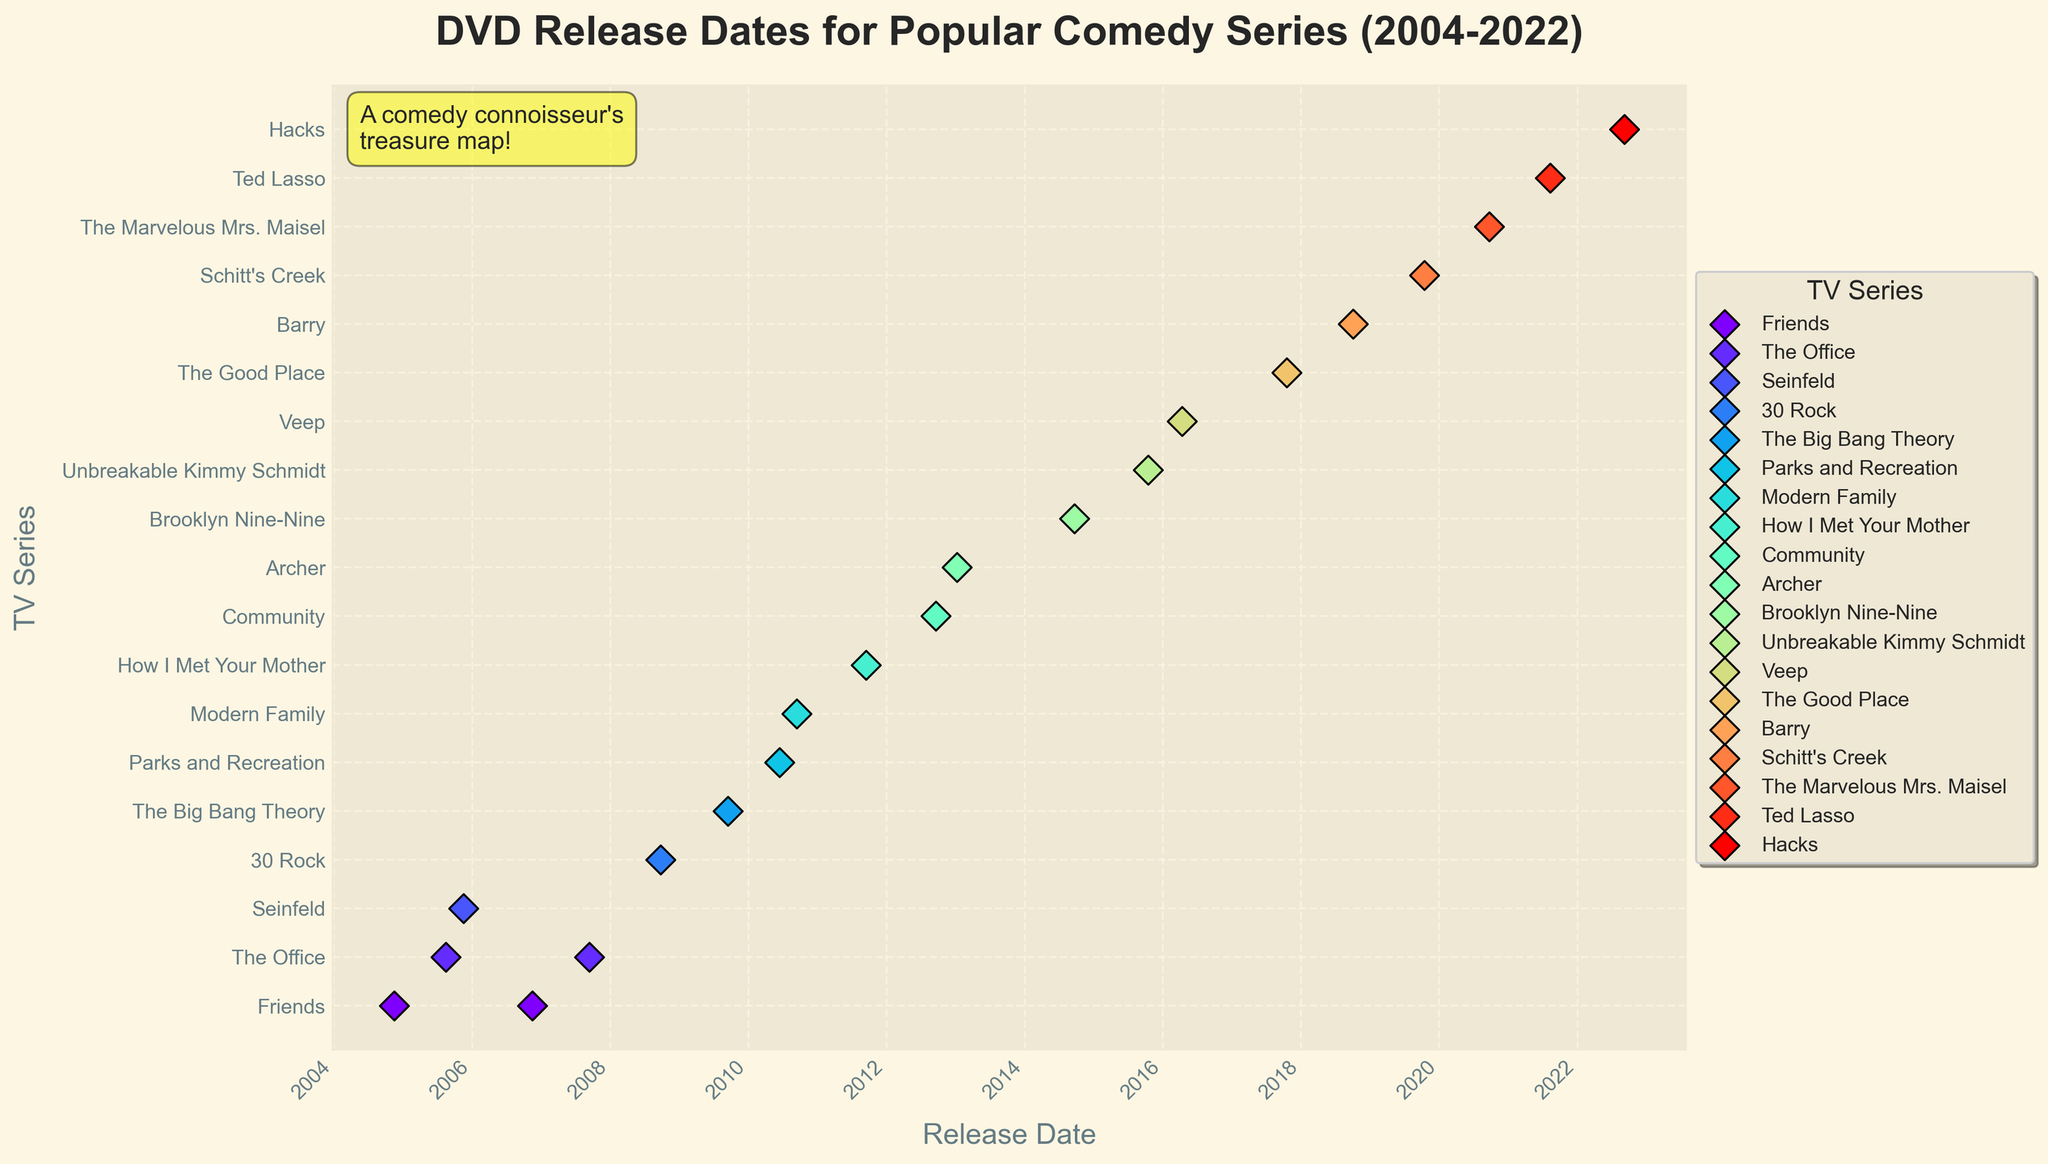What's the title of the figure? The title of the figure is found at the top and usually gives a brief description of what the figure is about. Here, it indicates the topic and timeframe.
Answer: DVD Release Dates for Popular Comedy Series (2004-2022) What are the x-axis and y-axis labels? The labels for the x-axis and y-axis provide information on what the axes represent. In this figure, the x-axis (Release Date) shows the dates, while the y-axis (TV Series) lists the names of the comedy series.
Answer: Release Date, TV Series Which series has the most recent DVD release date? To determine this, look at the latest (most recent) point on the graph along the x-axis.
Answer: Hacks Which series released its complete series DVD in 2006? Since the y-axis lists each series, locate the year 2006 on the x-axis and find the corresponding series in the y-axis label.
Answer: Friends How many series have their DVDs released after 2017? Count the number of data points plotted on the right side of the 2017 mark on the x-axis.
Answer: 5 Which series has the earliest release date? Find the data point farthest to the left on the x-axis, and see which series it is associated with on the y-axis.
Answer: Friends Are there any series that released multiple season DVDs in the same year? Look for multiple points within the same series aligned vertically in the same year on the x-axis.
Answer: No series has multiple season DVDs released in the same year Compare the release dates of "The Big Bang Theory" and "Modern Family" DVDs. Which was released first? Locate both series on the y-axis and check their corresponding points on the x-axis to see which one is earlier.
Answer: The Big Bang Theory What pattern do you observe regarding the release dates over the years? Observe if there is a clustering of release dates in certain periods or a general trend, such as more releases in recent years or clustering around certain months.
Answer: More releases appear to be clustered in the mid to late 2000s and early 2010s 